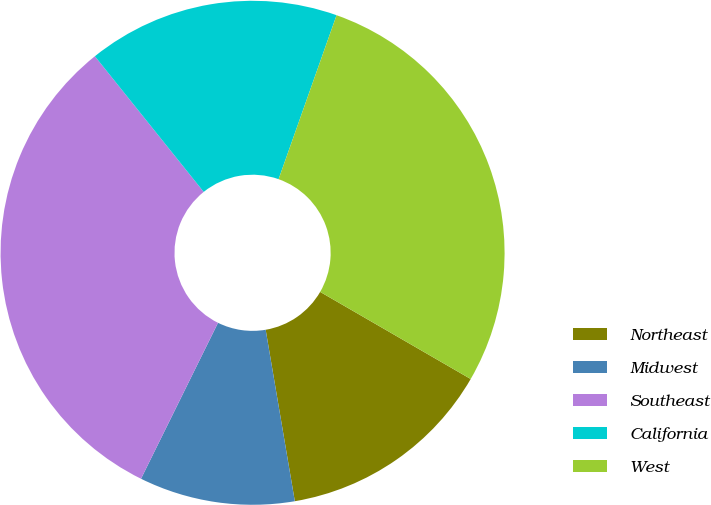Convert chart to OTSL. <chart><loc_0><loc_0><loc_500><loc_500><pie_chart><fcel>Northeast<fcel>Midwest<fcel>Southeast<fcel>California<fcel>West<nl><fcel>13.97%<fcel>9.98%<fcel>31.94%<fcel>16.17%<fcel>27.94%<nl></chart> 